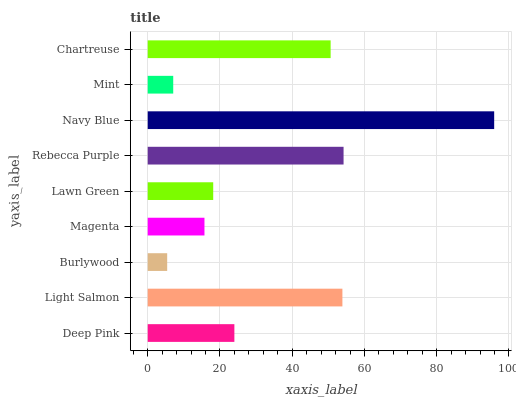Is Burlywood the minimum?
Answer yes or no. Yes. Is Navy Blue the maximum?
Answer yes or no. Yes. Is Light Salmon the minimum?
Answer yes or no. No. Is Light Salmon the maximum?
Answer yes or no. No. Is Light Salmon greater than Deep Pink?
Answer yes or no. Yes. Is Deep Pink less than Light Salmon?
Answer yes or no. Yes. Is Deep Pink greater than Light Salmon?
Answer yes or no. No. Is Light Salmon less than Deep Pink?
Answer yes or no. No. Is Deep Pink the high median?
Answer yes or no. Yes. Is Deep Pink the low median?
Answer yes or no. Yes. Is Burlywood the high median?
Answer yes or no. No. Is Magenta the low median?
Answer yes or no. No. 